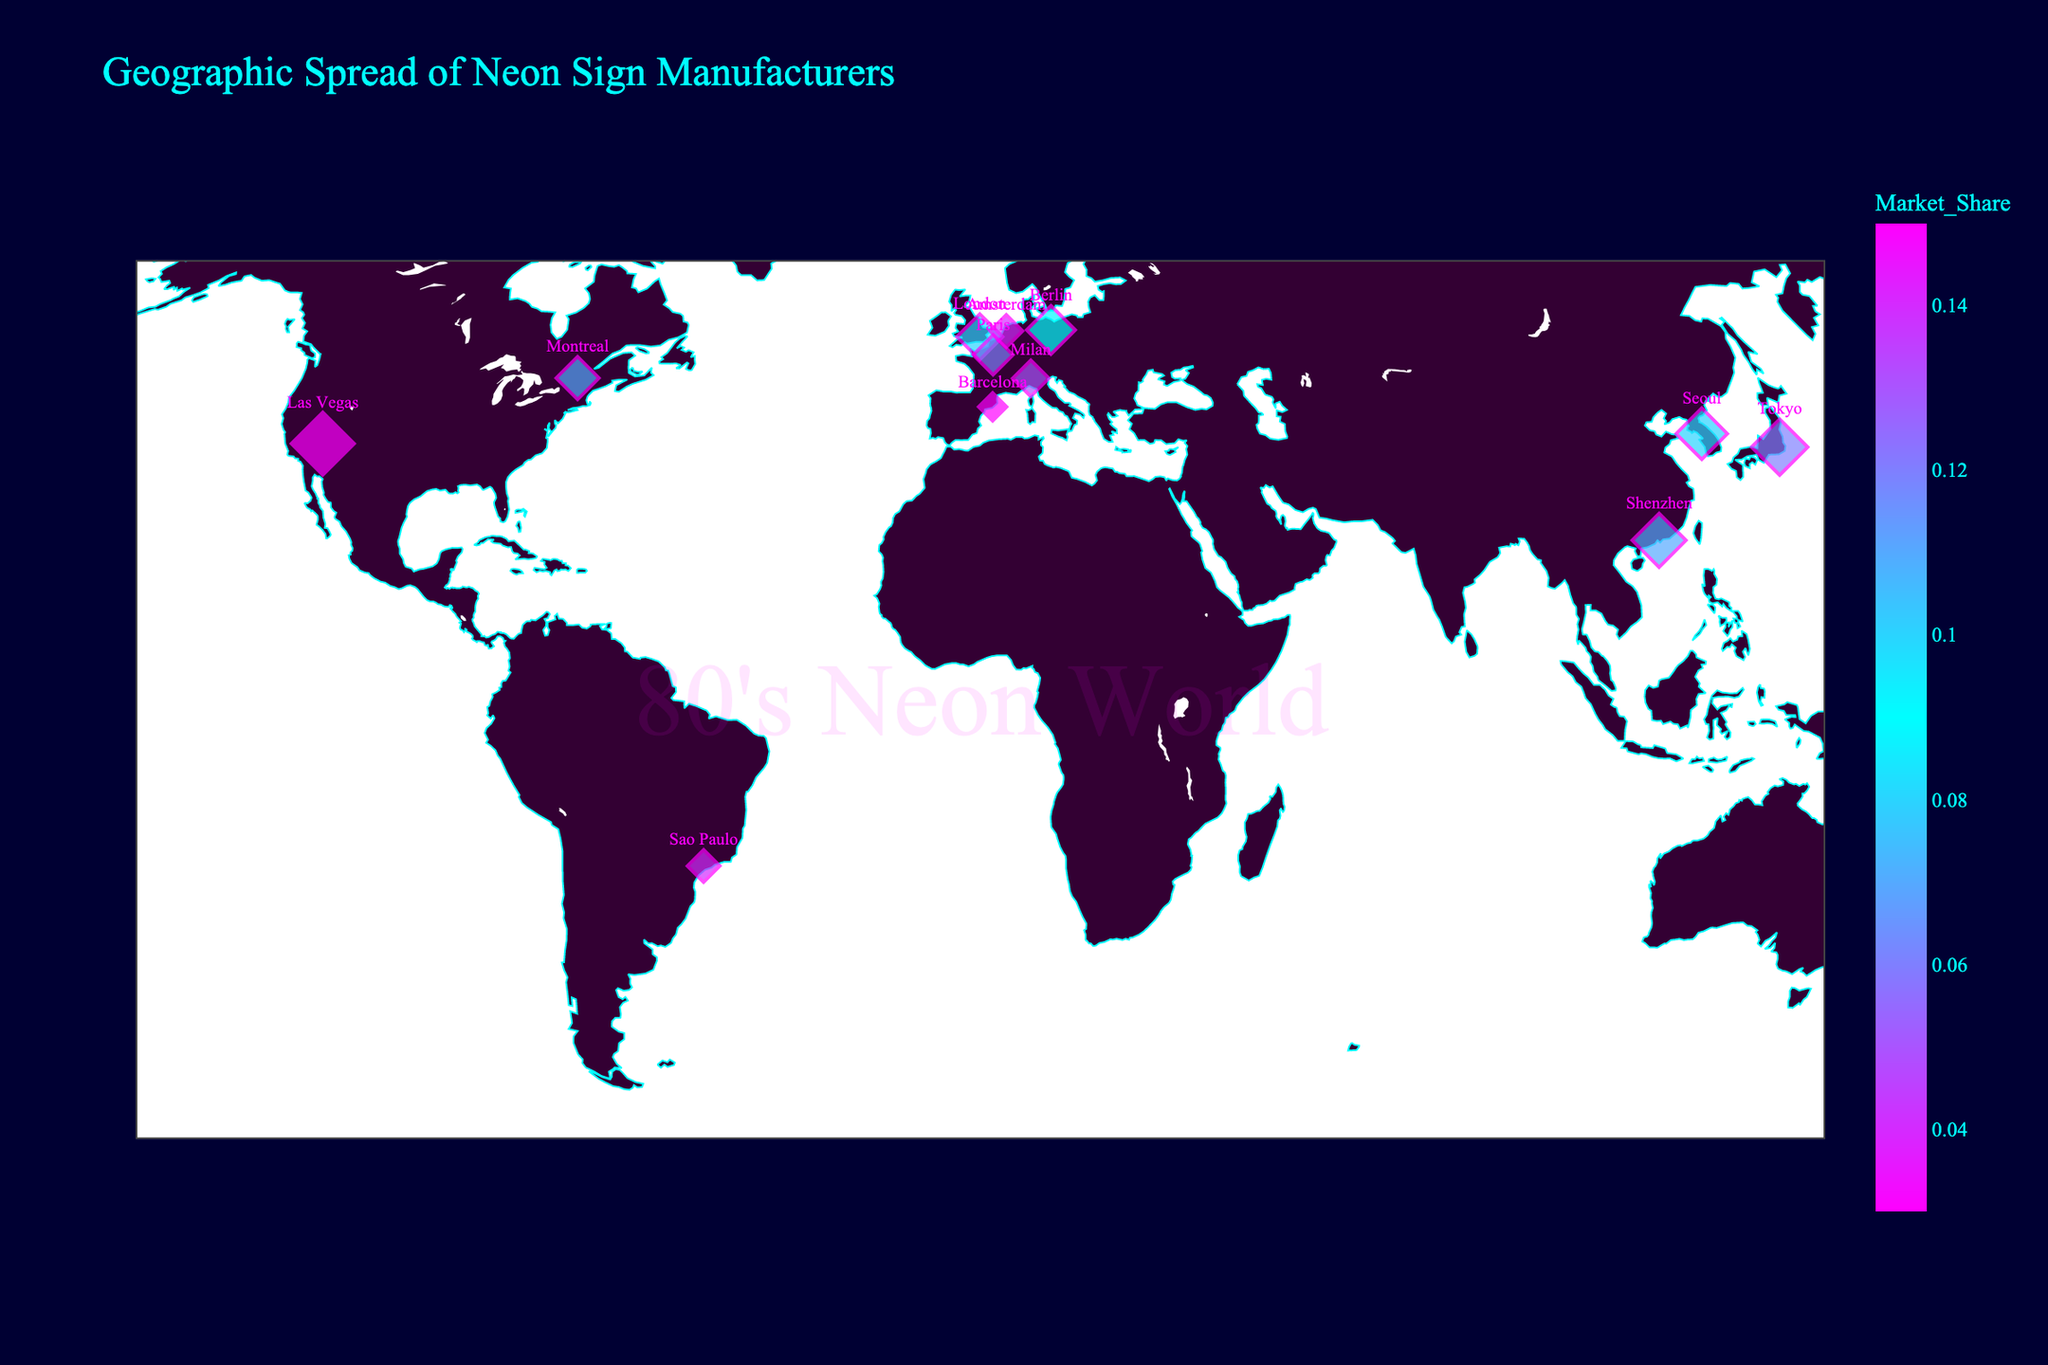How many countries are represented in the plot? Count the distinct countries presented on the scatter plot.
Answer: 12 What is the title of the plot? Read the title displayed at the top of the figure.
Answer: Geographic Spread of Neon Sign Manufacturers Which city has the largest sized marker on the plot? The largest sized marker visually represents the city with the highest market share.
Answer: Las Vegas How many cities have a market share greater than 0.10? Identify and count the cities with market share values larger than 0.10
Answer: 3 Which country's cities are marked closest to the bottom of the map? Locate the cities positioned near the bottom of the geographic plot.
Answer: Brazil (Sao Paulo) What is the geographic region with the highest concentration of neon sign companies? Identify the region with the highest number of markers close to each other.
Answer: Europe Compare the market shares of companies in Las Vegas and Berlin. Which has a higher market share? Look at the market share values of the companies located in Las Vegas and Berlin and compare them.
Answer: Las Vegas Compare the market share sizes of the companies in Tokyo and Seoul. Which company has a larger market share? Check the market share indicators for Tokyo and Seoul and compare their values.
Answer: Tokyo Name two unique graphical elements incorporated into the map's design that relate to the 80’s aesthetics and synthwave theme. Observe and identify unique graphical elements that add a thematic design to the map.
Answer: Custom color scale and watermark What type of marker symbol is used to represent the companies on the map? Identify the marker shape used in the scatter plot.
Answer: Diamond 